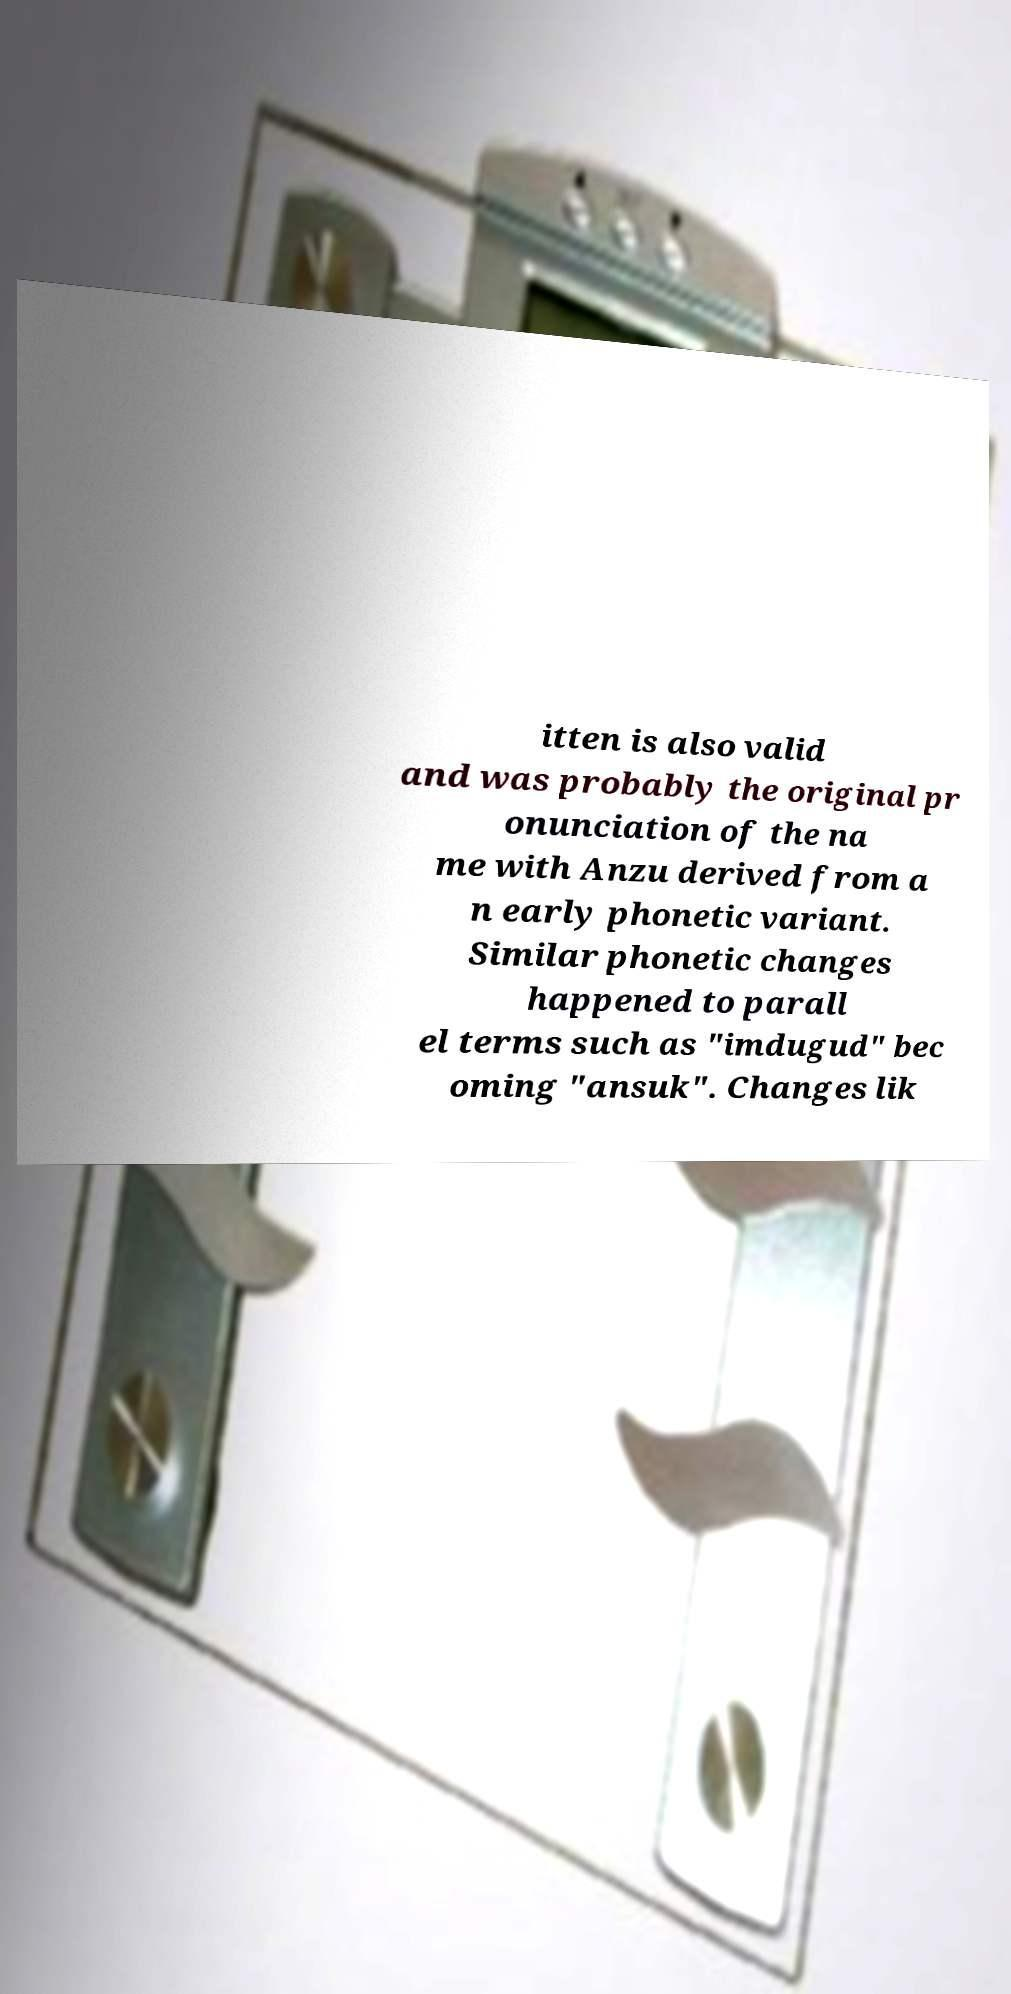Please read and relay the text visible in this image. What does it say? itten is also valid and was probably the original pr onunciation of the na me with Anzu derived from a n early phonetic variant. Similar phonetic changes happened to parall el terms such as "imdugud" bec oming "ansuk". Changes lik 